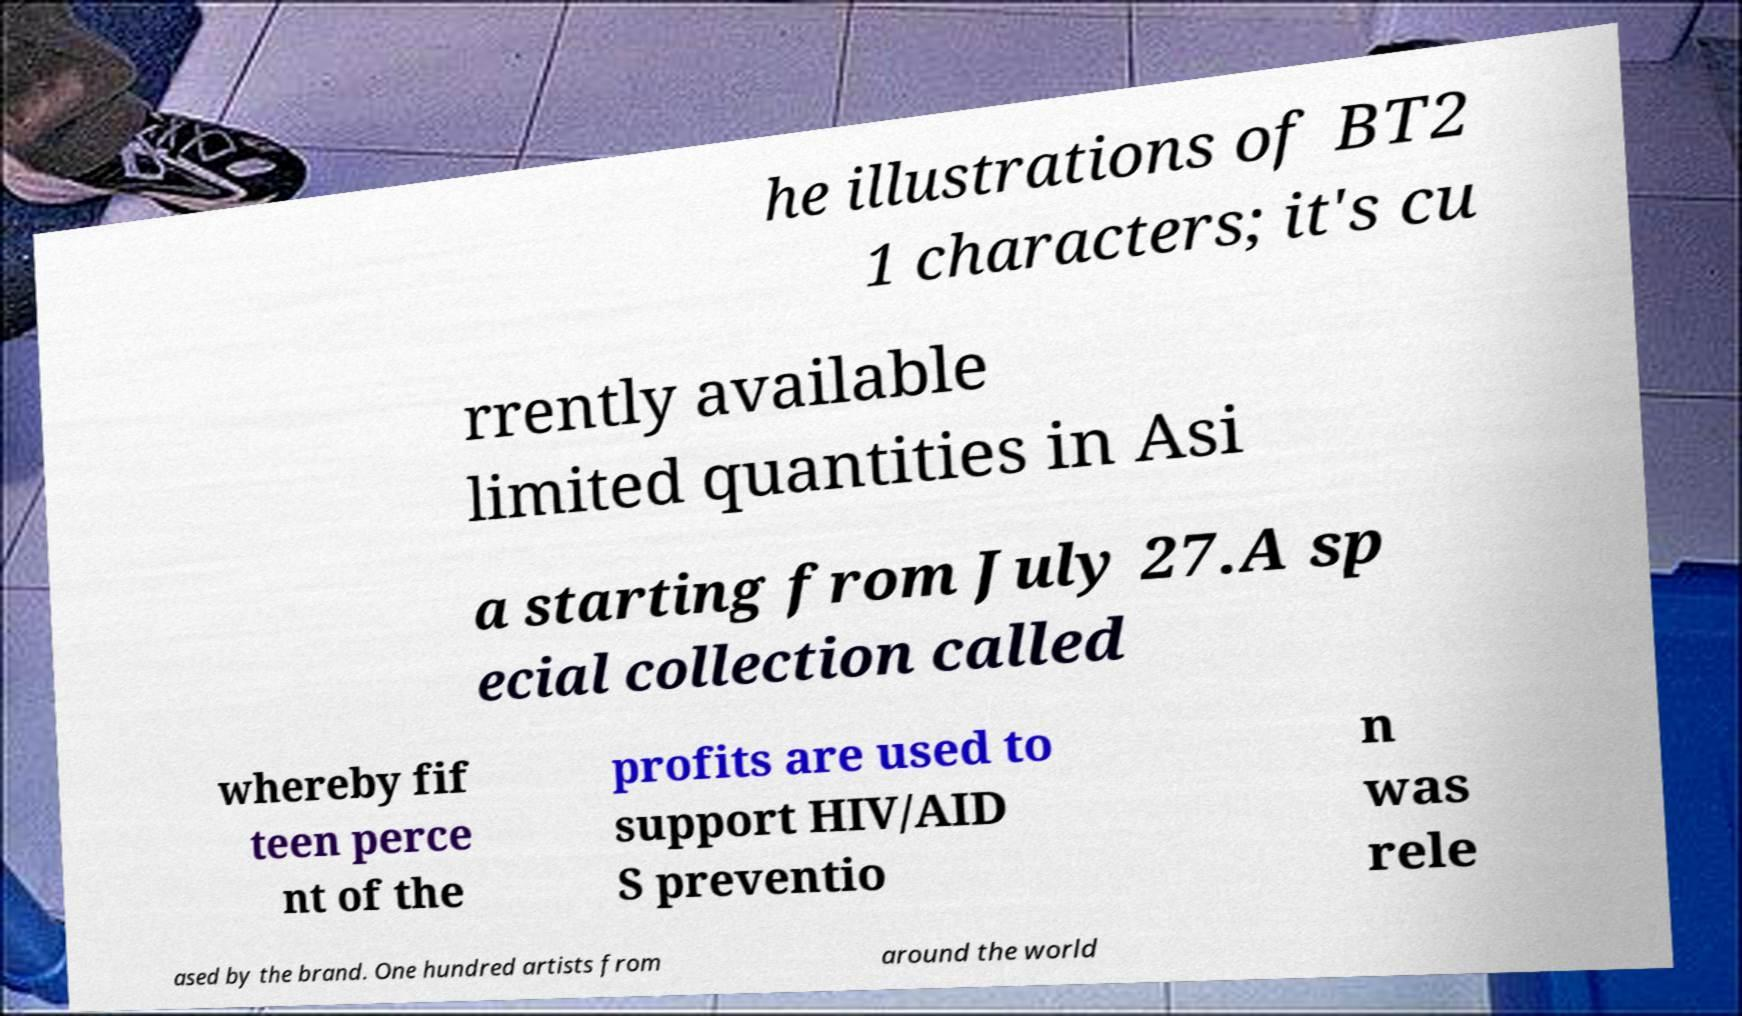There's text embedded in this image that I need extracted. Can you transcribe it verbatim? he illustrations of BT2 1 characters; it's cu rrently available limited quantities in Asi a starting from July 27.A sp ecial collection called whereby fif teen perce nt of the profits are used to support HIV/AID S preventio n was rele ased by the brand. One hundred artists from around the world 